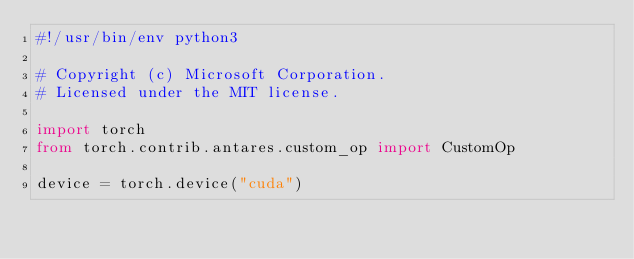Convert code to text. <code><loc_0><loc_0><loc_500><loc_500><_Python_>#!/usr/bin/env python3

# Copyright (c) Microsoft Corporation.
# Licensed under the MIT license.

import torch
from torch.contrib.antares.custom_op import CustomOp

device = torch.device("cuda")</code> 